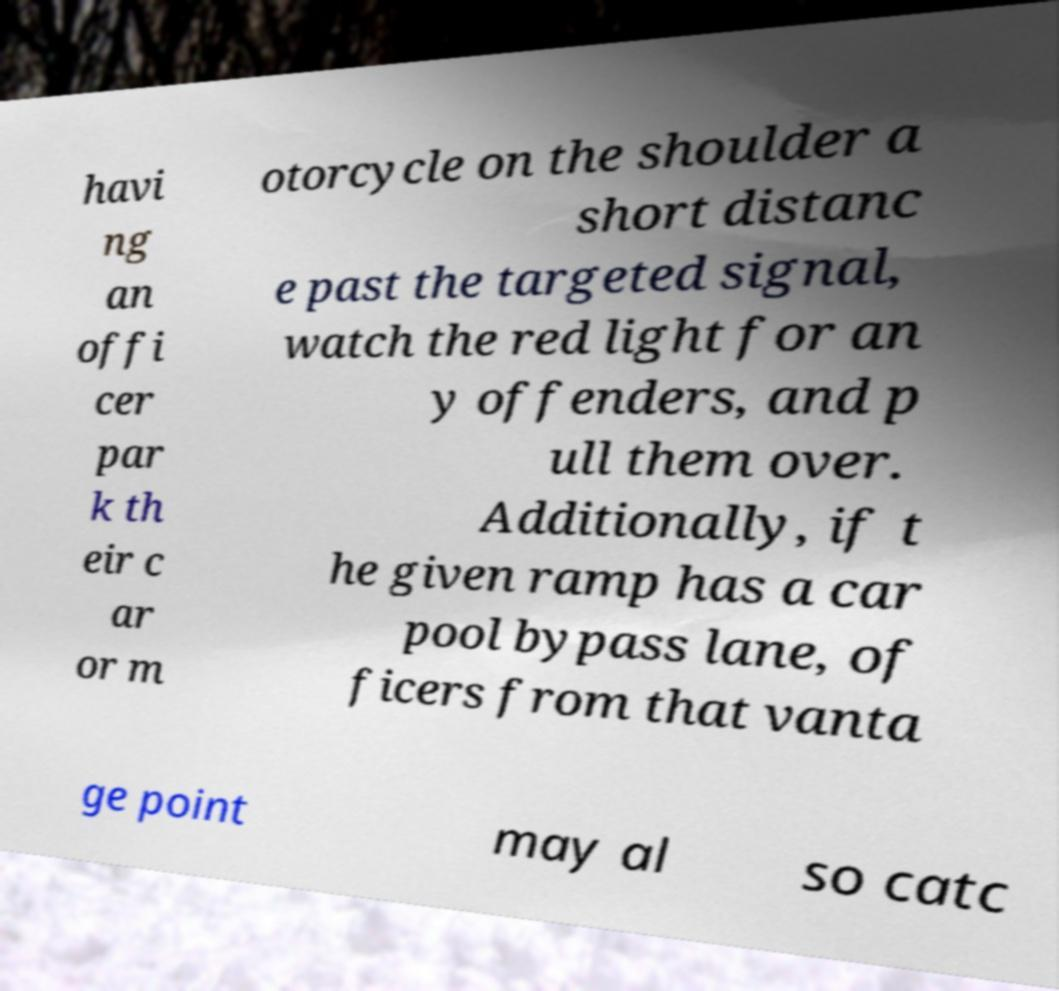Could you assist in decoding the text presented in this image and type it out clearly? havi ng an offi cer par k th eir c ar or m otorcycle on the shoulder a short distanc e past the targeted signal, watch the red light for an y offenders, and p ull them over. Additionally, if t he given ramp has a car pool bypass lane, of ficers from that vanta ge point may al so catc 